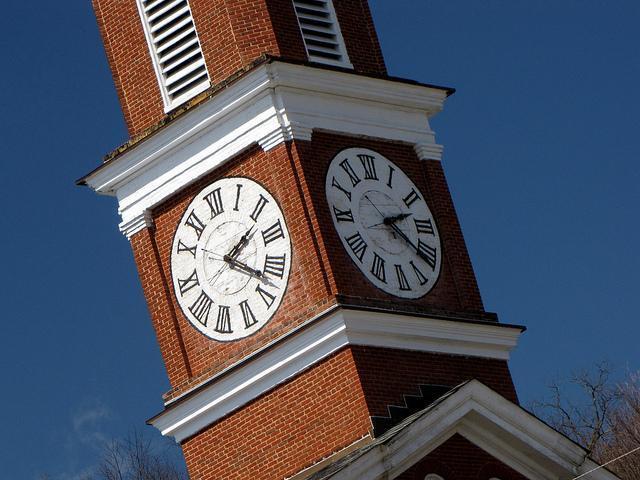How many clocks can be seen?
Give a very brief answer. 2. 